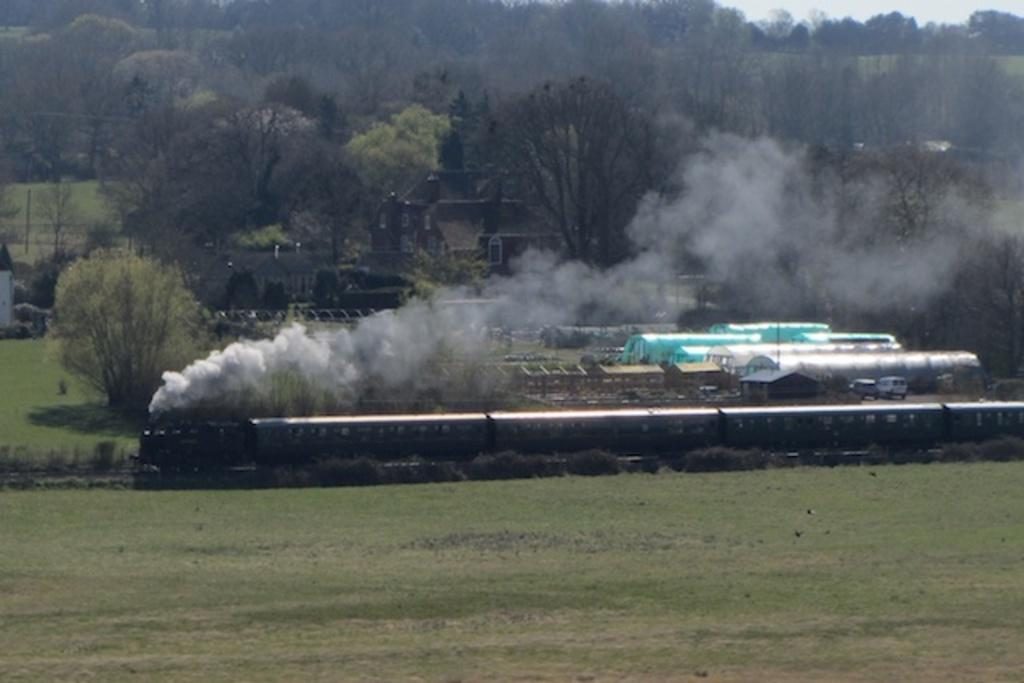What is the main subject of the image? The main subject of the image is a train on the track. What is the train doing in the image? The train is producing smoke in the image. What type of vegetation can be seen in the image? Plants, grass, and trees are visible in the image. Can you describe the house in the image? The house has windows and is located in the image. What is visible in the sky in the image? The sky is visible in the image. What type of plough is being used to cultivate the grass in the image? There is no plough present in the image, and the grass is not being cultivated. How does the train reduce friction while moving on the track in the image? The image does not provide information about how the train reduces friction while moving on the track. 